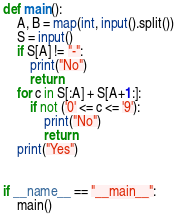<code> <loc_0><loc_0><loc_500><loc_500><_Python_>def main():
    A, B = map(int, input().split())
    S = input()
    if S[A] != "-":
        print("No")
        return
    for c in S[:A] + S[A+1:]:
        if not ('0' <= c <= '9'):
            print("No")
            return
    print("Yes")


if __name__ == "__main__":
    main()
</code> 